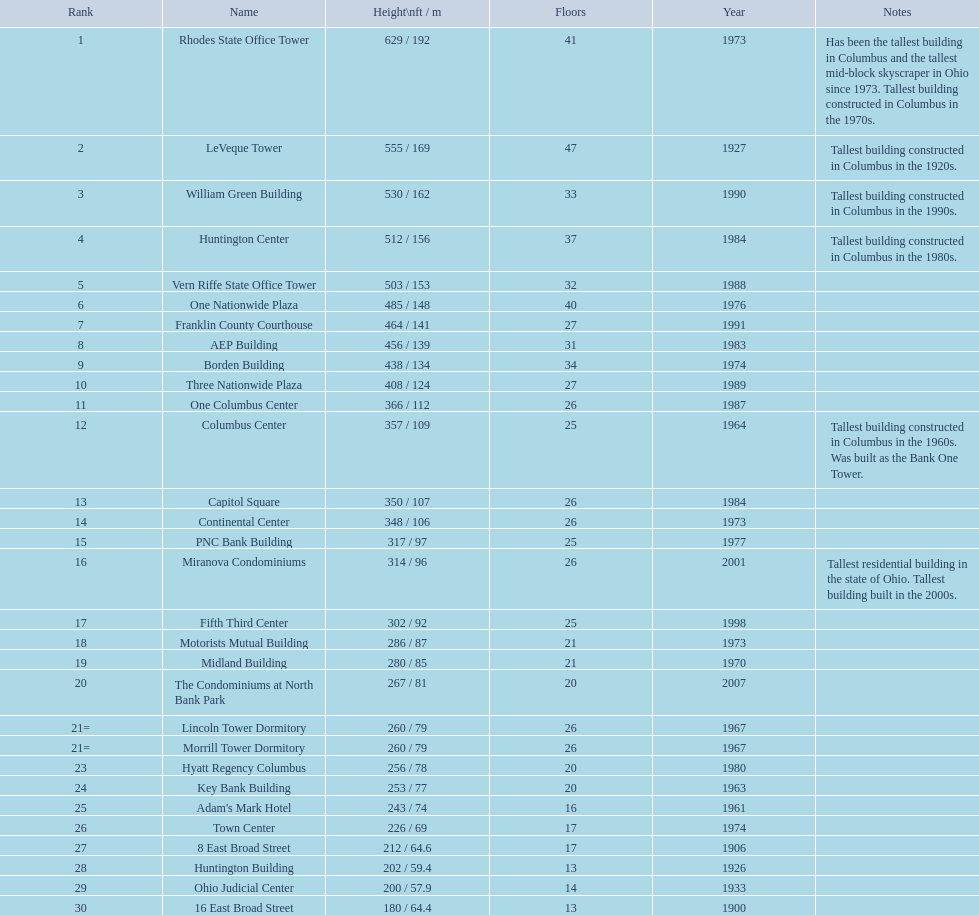Which of the tallest buildings in columbus, ohio were built in the 1980s? Huntington Center, Vern Riffe State Office Tower, AEP Building, Three Nationwide Plaza, One Columbus Center, Capitol Square, Hyatt Regency Columbus. Of these buildings, which have between 26 and 31 floors? AEP Building, Three Nationwide Plaza, One Columbus Center, Capitol Square. Of these buildings, which is the tallest? AEP Building. 